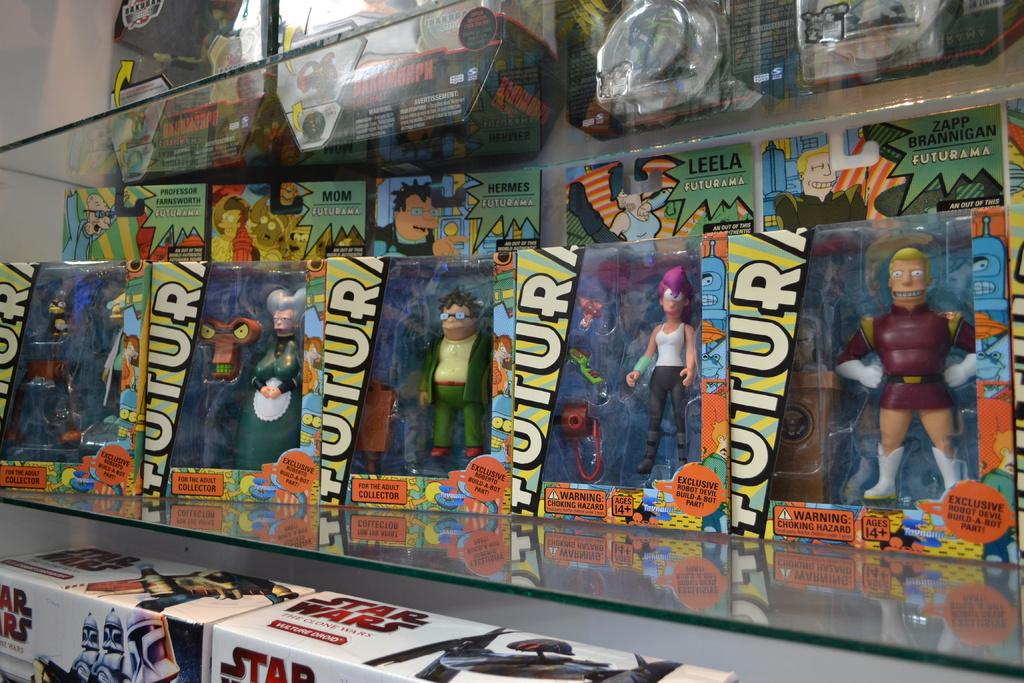What show are these characters from?
Provide a short and direct response. Futurama. What movie is the toy name on the bottom?
Your answer should be very brief. Star wars. 